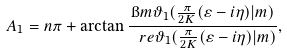<formula> <loc_0><loc_0><loc_500><loc_500>A _ { 1 } = n \pi + \arctan \frac { \i m \vartheta _ { 1 } ( \frac { \pi } { 2 K } ( \varepsilon - i \eta ) | m ) } { \ r e \vartheta _ { 1 } ( \frac { \pi } { 2 K } ( \varepsilon - i \eta ) | m ) } ,</formula> 